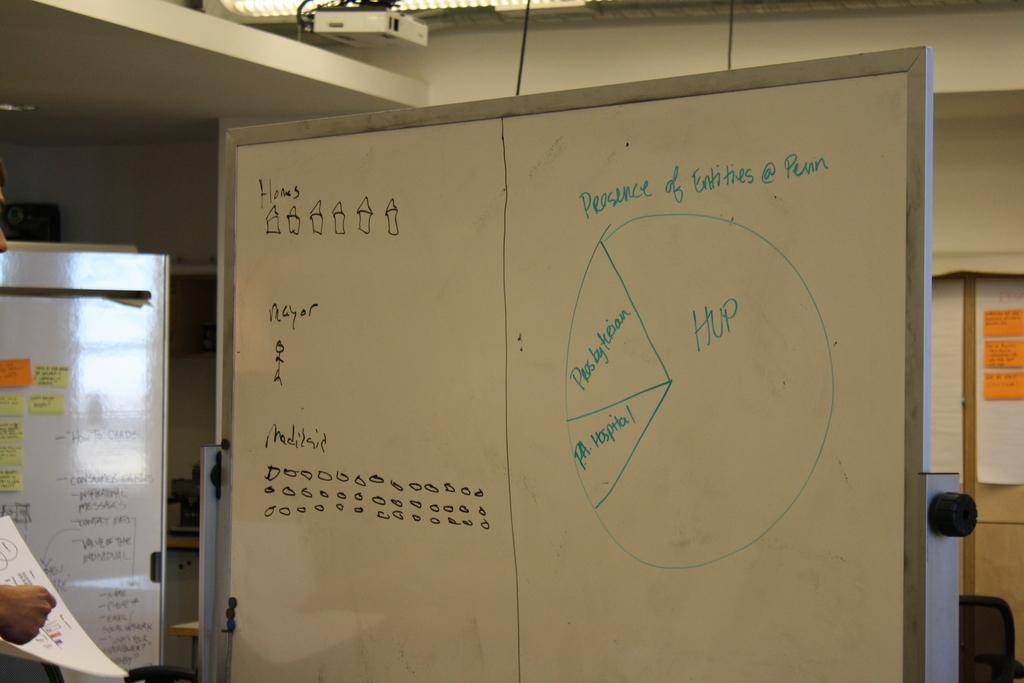What is the largest part of the pie chart?
Offer a terse response. Hup. What is the smallest part of the pie chart?
Offer a very short reply. Pa hospital. 